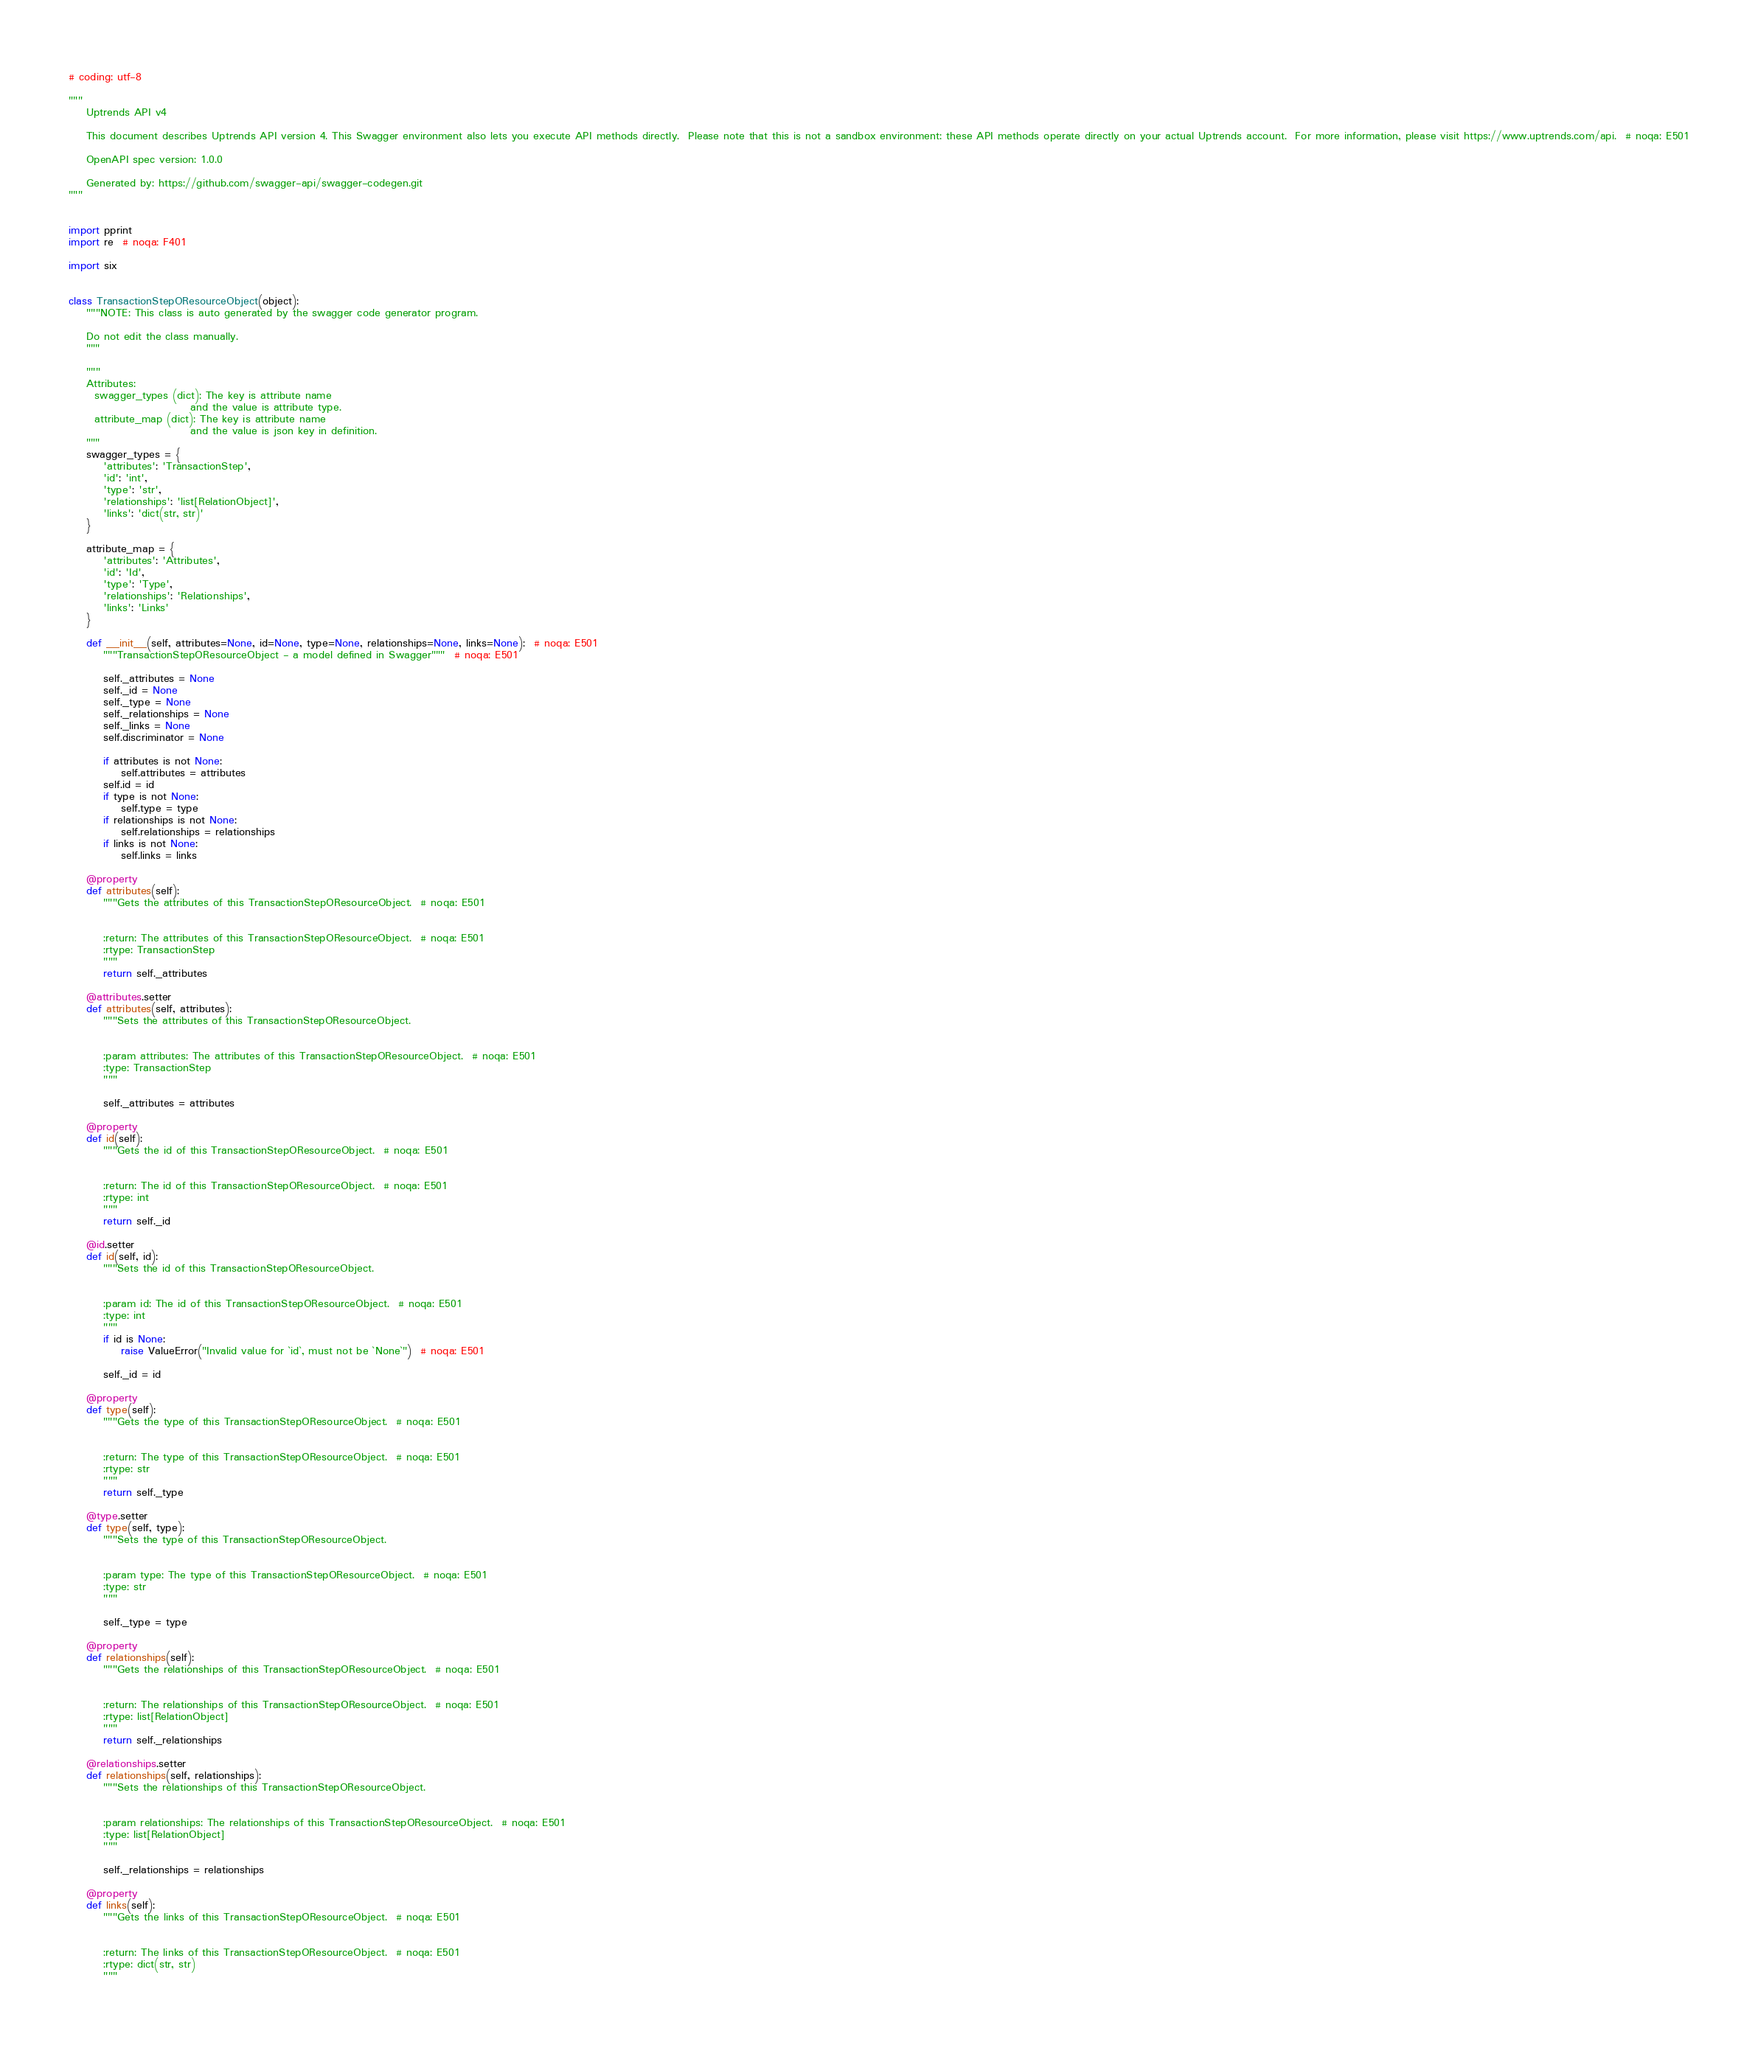<code> <loc_0><loc_0><loc_500><loc_500><_Python_># coding: utf-8

"""
    Uptrends API v4

    This document describes Uptrends API version 4. This Swagger environment also lets you execute API methods directly.  Please note that this is not a sandbox environment: these API methods operate directly on your actual Uptrends account.  For more information, please visit https://www.uptrends.com/api.  # noqa: E501

    OpenAPI spec version: 1.0.0
    
    Generated by: https://github.com/swagger-api/swagger-codegen.git
"""


import pprint
import re  # noqa: F401

import six


class TransactionStepOResourceObject(object):
    """NOTE: This class is auto generated by the swagger code generator program.

    Do not edit the class manually.
    """

    """
    Attributes:
      swagger_types (dict): The key is attribute name
                            and the value is attribute type.
      attribute_map (dict): The key is attribute name
                            and the value is json key in definition.
    """
    swagger_types = {
        'attributes': 'TransactionStep',
        'id': 'int',
        'type': 'str',
        'relationships': 'list[RelationObject]',
        'links': 'dict(str, str)'
    }

    attribute_map = {
        'attributes': 'Attributes',
        'id': 'Id',
        'type': 'Type',
        'relationships': 'Relationships',
        'links': 'Links'
    }

    def __init__(self, attributes=None, id=None, type=None, relationships=None, links=None):  # noqa: E501
        """TransactionStepOResourceObject - a model defined in Swagger"""  # noqa: E501

        self._attributes = None
        self._id = None
        self._type = None
        self._relationships = None
        self._links = None
        self.discriminator = None

        if attributes is not None:
            self.attributes = attributes
        self.id = id
        if type is not None:
            self.type = type
        if relationships is not None:
            self.relationships = relationships
        if links is not None:
            self.links = links

    @property
    def attributes(self):
        """Gets the attributes of this TransactionStepOResourceObject.  # noqa: E501


        :return: The attributes of this TransactionStepOResourceObject.  # noqa: E501
        :rtype: TransactionStep
        """
        return self._attributes

    @attributes.setter
    def attributes(self, attributes):
        """Sets the attributes of this TransactionStepOResourceObject.


        :param attributes: The attributes of this TransactionStepOResourceObject.  # noqa: E501
        :type: TransactionStep
        """

        self._attributes = attributes

    @property
    def id(self):
        """Gets the id of this TransactionStepOResourceObject.  # noqa: E501


        :return: The id of this TransactionStepOResourceObject.  # noqa: E501
        :rtype: int
        """
        return self._id

    @id.setter
    def id(self, id):
        """Sets the id of this TransactionStepOResourceObject.


        :param id: The id of this TransactionStepOResourceObject.  # noqa: E501
        :type: int
        """
        if id is None:
            raise ValueError("Invalid value for `id`, must not be `None`")  # noqa: E501

        self._id = id

    @property
    def type(self):
        """Gets the type of this TransactionStepOResourceObject.  # noqa: E501


        :return: The type of this TransactionStepOResourceObject.  # noqa: E501
        :rtype: str
        """
        return self._type

    @type.setter
    def type(self, type):
        """Sets the type of this TransactionStepOResourceObject.


        :param type: The type of this TransactionStepOResourceObject.  # noqa: E501
        :type: str
        """

        self._type = type

    @property
    def relationships(self):
        """Gets the relationships of this TransactionStepOResourceObject.  # noqa: E501


        :return: The relationships of this TransactionStepOResourceObject.  # noqa: E501
        :rtype: list[RelationObject]
        """
        return self._relationships

    @relationships.setter
    def relationships(self, relationships):
        """Sets the relationships of this TransactionStepOResourceObject.


        :param relationships: The relationships of this TransactionStepOResourceObject.  # noqa: E501
        :type: list[RelationObject]
        """

        self._relationships = relationships

    @property
    def links(self):
        """Gets the links of this TransactionStepOResourceObject.  # noqa: E501


        :return: The links of this TransactionStepOResourceObject.  # noqa: E501
        :rtype: dict(str, str)
        """</code> 